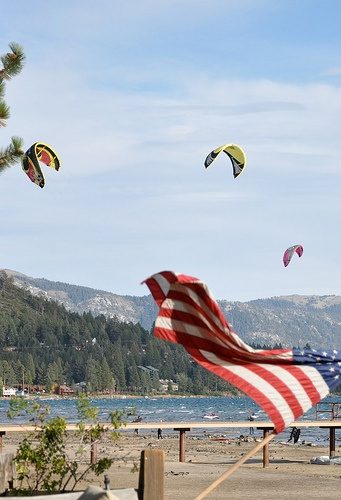Describe the objects in this image and their specific colors. I can see kite in lightblue, black, brown, olive, and gray tones, kite in lightblue, tan, black, ivory, and darkgray tones, kite in lightblue, gray, and purple tones, people in lightblue, gray, darkgray, and black tones, and people in lightblue, black, darkgray, and gray tones in this image. 